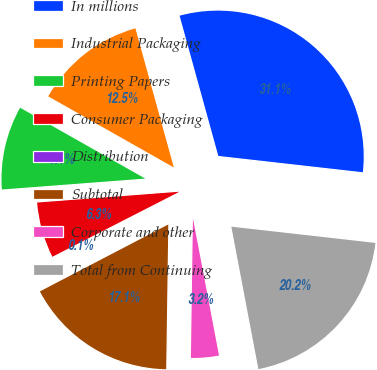<chart> <loc_0><loc_0><loc_500><loc_500><pie_chart><fcel>In millions<fcel>Industrial Packaging<fcel>Printing Papers<fcel>Consumer Packaging<fcel>Distribution<fcel>Subtotal<fcel>Corporate and other<fcel>Total from Continuing<nl><fcel>31.08%<fcel>12.51%<fcel>9.41%<fcel>6.32%<fcel>0.12%<fcel>17.12%<fcel>3.22%<fcel>20.22%<nl></chart> 